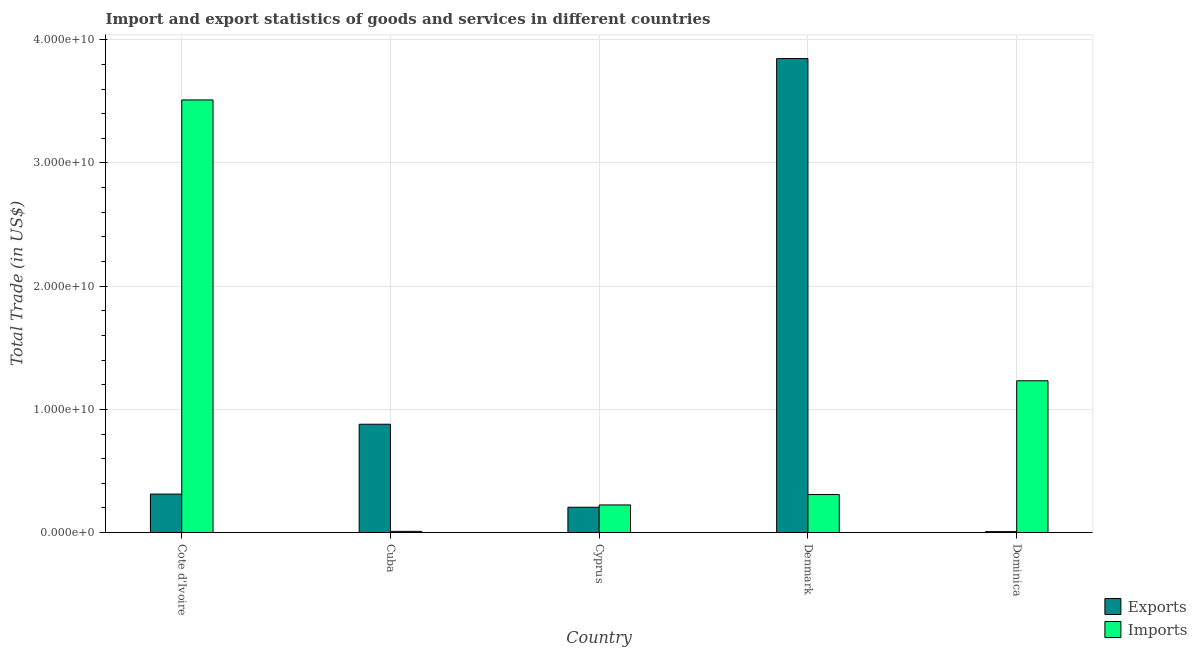How many different coloured bars are there?
Give a very brief answer. 2. Are the number of bars on each tick of the X-axis equal?
Offer a very short reply. Yes. How many bars are there on the 5th tick from the left?
Provide a succinct answer. 2. How many bars are there on the 2nd tick from the right?
Give a very brief answer. 2. What is the label of the 5th group of bars from the left?
Make the answer very short. Dominica. In how many cases, is the number of bars for a given country not equal to the number of legend labels?
Give a very brief answer. 0. What is the export of goods and services in Cyprus?
Provide a succinct answer. 2.06e+09. Across all countries, what is the maximum imports of goods and services?
Make the answer very short. 3.51e+1. Across all countries, what is the minimum imports of goods and services?
Give a very brief answer. 9.89e+07. In which country was the imports of goods and services maximum?
Ensure brevity in your answer.  Cote d'Ivoire. In which country was the export of goods and services minimum?
Keep it short and to the point. Dominica. What is the total imports of goods and services in the graph?
Provide a short and direct response. 5.29e+1. What is the difference between the export of goods and services in Denmark and that in Dominica?
Your response must be concise. 3.84e+1. What is the difference between the imports of goods and services in Denmark and the export of goods and services in Cote d'Ivoire?
Give a very brief answer. -3.90e+07. What is the average imports of goods and services per country?
Ensure brevity in your answer.  1.06e+1. What is the difference between the export of goods and services and imports of goods and services in Cyprus?
Ensure brevity in your answer.  -1.86e+08. What is the ratio of the imports of goods and services in Cuba to that in Denmark?
Your answer should be very brief. 0.03. Is the difference between the export of goods and services in Cote d'Ivoire and Denmark greater than the difference between the imports of goods and services in Cote d'Ivoire and Denmark?
Offer a very short reply. No. What is the difference between the highest and the second highest imports of goods and services?
Make the answer very short. 2.28e+1. What is the difference between the highest and the lowest export of goods and services?
Keep it short and to the point. 3.84e+1. What does the 1st bar from the left in Cuba represents?
Ensure brevity in your answer.  Exports. What does the 2nd bar from the right in Cote d'Ivoire represents?
Your answer should be compact. Exports. How many countries are there in the graph?
Your answer should be very brief. 5. What is the difference between two consecutive major ticks on the Y-axis?
Make the answer very short. 1.00e+1. How many legend labels are there?
Ensure brevity in your answer.  2. What is the title of the graph?
Keep it short and to the point. Import and export statistics of goods and services in different countries. What is the label or title of the Y-axis?
Your answer should be compact. Total Trade (in US$). What is the Total Trade (in US$) of Exports in Cote d'Ivoire?
Provide a short and direct response. 3.13e+09. What is the Total Trade (in US$) of Imports in Cote d'Ivoire?
Provide a short and direct response. 3.51e+1. What is the Total Trade (in US$) in Exports in Cuba?
Keep it short and to the point. 8.79e+09. What is the Total Trade (in US$) of Imports in Cuba?
Offer a terse response. 9.89e+07. What is the Total Trade (in US$) of Exports in Cyprus?
Provide a succinct answer. 2.06e+09. What is the Total Trade (in US$) of Imports in Cyprus?
Keep it short and to the point. 2.24e+09. What is the Total Trade (in US$) of Exports in Denmark?
Your response must be concise. 3.85e+1. What is the Total Trade (in US$) in Imports in Denmark?
Offer a very short reply. 3.09e+09. What is the Total Trade (in US$) of Exports in Dominica?
Your answer should be very brief. 7.86e+07. What is the Total Trade (in US$) of Imports in Dominica?
Your answer should be very brief. 1.23e+1. Across all countries, what is the maximum Total Trade (in US$) in Exports?
Keep it short and to the point. 3.85e+1. Across all countries, what is the maximum Total Trade (in US$) of Imports?
Provide a succinct answer. 3.51e+1. Across all countries, what is the minimum Total Trade (in US$) of Exports?
Provide a succinct answer. 7.86e+07. Across all countries, what is the minimum Total Trade (in US$) in Imports?
Your response must be concise. 9.89e+07. What is the total Total Trade (in US$) of Exports in the graph?
Provide a short and direct response. 5.25e+1. What is the total Total Trade (in US$) in Imports in the graph?
Provide a short and direct response. 5.29e+1. What is the difference between the Total Trade (in US$) of Exports in Cote d'Ivoire and that in Cuba?
Give a very brief answer. -5.67e+09. What is the difference between the Total Trade (in US$) in Imports in Cote d'Ivoire and that in Cuba?
Make the answer very short. 3.50e+1. What is the difference between the Total Trade (in US$) of Exports in Cote d'Ivoire and that in Cyprus?
Your response must be concise. 1.07e+09. What is the difference between the Total Trade (in US$) of Imports in Cote d'Ivoire and that in Cyprus?
Ensure brevity in your answer.  3.29e+1. What is the difference between the Total Trade (in US$) in Exports in Cote d'Ivoire and that in Denmark?
Offer a very short reply. -3.53e+1. What is the difference between the Total Trade (in US$) in Imports in Cote d'Ivoire and that in Denmark?
Your answer should be compact. 3.20e+1. What is the difference between the Total Trade (in US$) of Exports in Cote d'Ivoire and that in Dominica?
Offer a terse response. 3.05e+09. What is the difference between the Total Trade (in US$) in Imports in Cote d'Ivoire and that in Dominica?
Offer a terse response. 2.28e+1. What is the difference between the Total Trade (in US$) of Exports in Cuba and that in Cyprus?
Make the answer very short. 6.74e+09. What is the difference between the Total Trade (in US$) in Imports in Cuba and that in Cyprus?
Your answer should be very brief. -2.14e+09. What is the difference between the Total Trade (in US$) in Exports in Cuba and that in Denmark?
Ensure brevity in your answer.  -2.97e+1. What is the difference between the Total Trade (in US$) in Imports in Cuba and that in Denmark?
Provide a succinct answer. -2.99e+09. What is the difference between the Total Trade (in US$) of Exports in Cuba and that in Dominica?
Offer a very short reply. 8.72e+09. What is the difference between the Total Trade (in US$) in Imports in Cuba and that in Dominica?
Give a very brief answer. -1.22e+1. What is the difference between the Total Trade (in US$) in Exports in Cyprus and that in Denmark?
Make the answer very short. -3.64e+1. What is the difference between the Total Trade (in US$) in Imports in Cyprus and that in Denmark?
Provide a short and direct response. -8.44e+08. What is the difference between the Total Trade (in US$) of Exports in Cyprus and that in Dominica?
Ensure brevity in your answer.  1.98e+09. What is the difference between the Total Trade (in US$) in Imports in Cyprus and that in Dominica?
Offer a very short reply. -1.01e+1. What is the difference between the Total Trade (in US$) in Exports in Denmark and that in Dominica?
Make the answer very short. 3.84e+1. What is the difference between the Total Trade (in US$) of Imports in Denmark and that in Dominica?
Offer a terse response. -9.23e+09. What is the difference between the Total Trade (in US$) in Exports in Cote d'Ivoire and the Total Trade (in US$) in Imports in Cuba?
Your answer should be compact. 3.03e+09. What is the difference between the Total Trade (in US$) of Exports in Cote d'Ivoire and the Total Trade (in US$) of Imports in Cyprus?
Your answer should be compact. 8.83e+08. What is the difference between the Total Trade (in US$) in Exports in Cote d'Ivoire and the Total Trade (in US$) in Imports in Denmark?
Keep it short and to the point. 3.90e+07. What is the difference between the Total Trade (in US$) in Exports in Cote d'Ivoire and the Total Trade (in US$) in Imports in Dominica?
Ensure brevity in your answer.  -9.20e+09. What is the difference between the Total Trade (in US$) of Exports in Cuba and the Total Trade (in US$) of Imports in Cyprus?
Provide a short and direct response. 6.55e+09. What is the difference between the Total Trade (in US$) of Exports in Cuba and the Total Trade (in US$) of Imports in Denmark?
Offer a terse response. 5.71e+09. What is the difference between the Total Trade (in US$) of Exports in Cuba and the Total Trade (in US$) of Imports in Dominica?
Offer a very short reply. -3.53e+09. What is the difference between the Total Trade (in US$) of Exports in Cyprus and the Total Trade (in US$) of Imports in Denmark?
Your response must be concise. -1.03e+09. What is the difference between the Total Trade (in US$) in Exports in Cyprus and the Total Trade (in US$) in Imports in Dominica?
Your answer should be compact. -1.03e+1. What is the difference between the Total Trade (in US$) in Exports in Denmark and the Total Trade (in US$) in Imports in Dominica?
Give a very brief answer. 2.61e+1. What is the average Total Trade (in US$) of Exports per country?
Provide a short and direct response. 1.05e+1. What is the average Total Trade (in US$) of Imports per country?
Your answer should be very brief. 1.06e+1. What is the difference between the Total Trade (in US$) of Exports and Total Trade (in US$) of Imports in Cote d'Ivoire?
Offer a terse response. -3.20e+1. What is the difference between the Total Trade (in US$) of Exports and Total Trade (in US$) of Imports in Cuba?
Offer a very short reply. 8.70e+09. What is the difference between the Total Trade (in US$) in Exports and Total Trade (in US$) in Imports in Cyprus?
Provide a succinct answer. -1.86e+08. What is the difference between the Total Trade (in US$) in Exports and Total Trade (in US$) in Imports in Denmark?
Keep it short and to the point. 3.54e+1. What is the difference between the Total Trade (in US$) in Exports and Total Trade (in US$) in Imports in Dominica?
Your answer should be compact. -1.22e+1. What is the ratio of the Total Trade (in US$) of Exports in Cote d'Ivoire to that in Cuba?
Give a very brief answer. 0.36. What is the ratio of the Total Trade (in US$) in Imports in Cote d'Ivoire to that in Cuba?
Make the answer very short. 355.08. What is the ratio of the Total Trade (in US$) in Exports in Cote d'Ivoire to that in Cyprus?
Ensure brevity in your answer.  1.52. What is the ratio of the Total Trade (in US$) in Imports in Cote d'Ivoire to that in Cyprus?
Provide a short and direct response. 15.65. What is the ratio of the Total Trade (in US$) in Exports in Cote d'Ivoire to that in Denmark?
Your answer should be compact. 0.08. What is the ratio of the Total Trade (in US$) of Imports in Cote d'Ivoire to that in Denmark?
Your answer should be very brief. 11.37. What is the ratio of the Total Trade (in US$) of Exports in Cote d'Ivoire to that in Dominica?
Your answer should be very brief. 39.8. What is the ratio of the Total Trade (in US$) of Imports in Cote d'Ivoire to that in Dominica?
Provide a short and direct response. 2.85. What is the ratio of the Total Trade (in US$) in Exports in Cuba to that in Cyprus?
Ensure brevity in your answer.  4.27. What is the ratio of the Total Trade (in US$) in Imports in Cuba to that in Cyprus?
Make the answer very short. 0.04. What is the ratio of the Total Trade (in US$) in Exports in Cuba to that in Denmark?
Make the answer very short. 0.23. What is the ratio of the Total Trade (in US$) in Imports in Cuba to that in Denmark?
Ensure brevity in your answer.  0.03. What is the ratio of the Total Trade (in US$) of Exports in Cuba to that in Dominica?
Offer a very short reply. 111.95. What is the ratio of the Total Trade (in US$) of Imports in Cuba to that in Dominica?
Offer a terse response. 0.01. What is the ratio of the Total Trade (in US$) of Exports in Cyprus to that in Denmark?
Provide a succinct answer. 0.05. What is the ratio of the Total Trade (in US$) in Imports in Cyprus to that in Denmark?
Your answer should be very brief. 0.73. What is the ratio of the Total Trade (in US$) in Exports in Cyprus to that in Dominica?
Offer a terse response. 26.19. What is the ratio of the Total Trade (in US$) in Imports in Cyprus to that in Dominica?
Ensure brevity in your answer.  0.18. What is the ratio of the Total Trade (in US$) in Exports in Denmark to that in Dominica?
Offer a very short reply. 489.71. What is the ratio of the Total Trade (in US$) in Imports in Denmark to that in Dominica?
Your answer should be compact. 0.25. What is the difference between the highest and the second highest Total Trade (in US$) of Exports?
Your answer should be compact. 2.97e+1. What is the difference between the highest and the second highest Total Trade (in US$) in Imports?
Provide a short and direct response. 2.28e+1. What is the difference between the highest and the lowest Total Trade (in US$) in Exports?
Offer a terse response. 3.84e+1. What is the difference between the highest and the lowest Total Trade (in US$) of Imports?
Ensure brevity in your answer.  3.50e+1. 